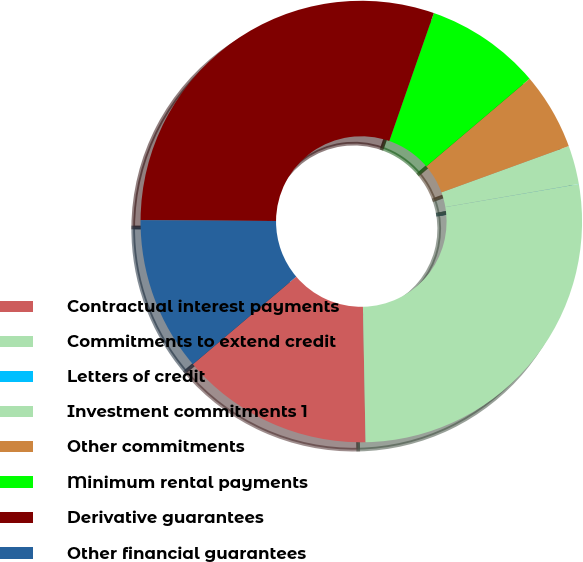<chart> <loc_0><loc_0><loc_500><loc_500><pie_chart><fcel>Contractual interest payments<fcel>Commitments to extend credit<fcel>Letters of credit<fcel>Investment commitments 1<fcel>Other commitments<fcel>Minimum rental payments<fcel>Derivative guarantees<fcel>Other financial guarantees<nl><fcel>14.12%<fcel>27.41%<fcel>0.01%<fcel>2.83%<fcel>5.65%<fcel>8.47%<fcel>30.23%<fcel>11.29%<nl></chart> 